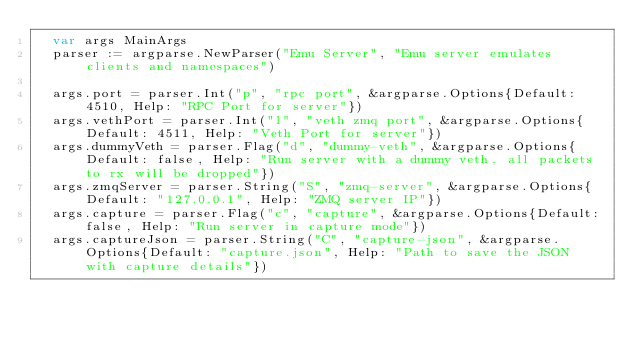Convert code to text. <code><loc_0><loc_0><loc_500><loc_500><_Go_>	var args MainArgs
	parser := argparse.NewParser("Emu Server", "Emu server emulates clients and namespaces")

	args.port = parser.Int("p", "rpc port", &argparse.Options{Default: 4510, Help: "RPC Port for server"})
	args.vethPort = parser.Int("l", "veth zmq port", &argparse.Options{Default: 4511, Help: "Veth Port for server"})
	args.dummyVeth = parser.Flag("d", "dummy-veth", &argparse.Options{Default: false, Help: "Run server with a dummy veth, all packets to rx will be dropped"})
	args.zmqServer = parser.String("S", "zmq-server", &argparse.Options{Default: "127.0.0.1", Help: "ZMQ server IP"})
	args.capture = parser.Flag("c", "capture", &argparse.Options{Default: false, Help: "Run server in capture mode"})
	args.captureJson = parser.String("C", "capture-json", &argparse.Options{Default: "capture.json", Help: "Path to save the JSON with capture details"})</code> 